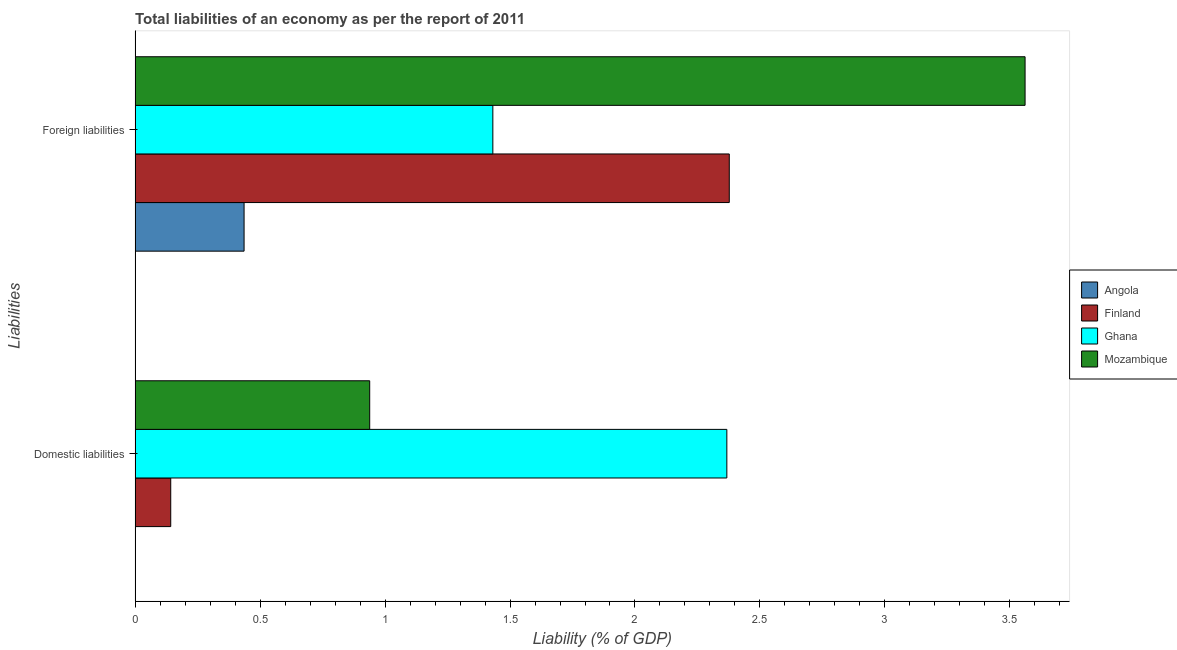How many groups of bars are there?
Give a very brief answer. 2. Are the number of bars on each tick of the Y-axis equal?
Your response must be concise. No. How many bars are there on the 1st tick from the top?
Provide a short and direct response. 4. What is the label of the 1st group of bars from the top?
Your answer should be compact. Foreign liabilities. What is the incurrence of foreign liabilities in Mozambique?
Make the answer very short. 3.56. Across all countries, what is the maximum incurrence of domestic liabilities?
Ensure brevity in your answer.  2.37. Across all countries, what is the minimum incurrence of foreign liabilities?
Offer a terse response. 0.44. In which country was the incurrence of foreign liabilities maximum?
Offer a terse response. Mozambique. What is the total incurrence of domestic liabilities in the graph?
Your response must be concise. 3.45. What is the difference between the incurrence of domestic liabilities in Ghana and that in Finland?
Keep it short and to the point. 2.22. What is the difference between the incurrence of foreign liabilities in Finland and the incurrence of domestic liabilities in Mozambique?
Your response must be concise. 1.44. What is the average incurrence of foreign liabilities per country?
Give a very brief answer. 1.95. What is the difference between the incurrence of foreign liabilities and incurrence of domestic liabilities in Finland?
Give a very brief answer. 2.23. In how many countries, is the incurrence of foreign liabilities greater than 1.1 %?
Keep it short and to the point. 3. What is the ratio of the incurrence of domestic liabilities in Ghana to that in Finland?
Your answer should be compact. 16.59. Is the incurrence of foreign liabilities in Finland less than that in Angola?
Ensure brevity in your answer.  No. Are all the bars in the graph horizontal?
Ensure brevity in your answer.  Yes. How many countries are there in the graph?
Make the answer very short. 4. What is the difference between two consecutive major ticks on the X-axis?
Your response must be concise. 0.5. Does the graph contain grids?
Offer a very short reply. No. How are the legend labels stacked?
Provide a short and direct response. Vertical. What is the title of the graph?
Your answer should be compact. Total liabilities of an economy as per the report of 2011. What is the label or title of the X-axis?
Offer a terse response. Liability (% of GDP). What is the label or title of the Y-axis?
Make the answer very short. Liabilities. What is the Liability (% of GDP) in Angola in Domestic liabilities?
Your answer should be compact. 0. What is the Liability (% of GDP) of Finland in Domestic liabilities?
Offer a terse response. 0.14. What is the Liability (% of GDP) in Ghana in Domestic liabilities?
Your answer should be very brief. 2.37. What is the Liability (% of GDP) of Mozambique in Domestic liabilities?
Make the answer very short. 0.94. What is the Liability (% of GDP) in Angola in Foreign liabilities?
Ensure brevity in your answer.  0.44. What is the Liability (% of GDP) of Finland in Foreign liabilities?
Give a very brief answer. 2.38. What is the Liability (% of GDP) in Ghana in Foreign liabilities?
Provide a short and direct response. 1.43. What is the Liability (% of GDP) in Mozambique in Foreign liabilities?
Ensure brevity in your answer.  3.56. Across all Liabilities, what is the maximum Liability (% of GDP) in Angola?
Offer a terse response. 0.44. Across all Liabilities, what is the maximum Liability (% of GDP) in Finland?
Give a very brief answer. 2.38. Across all Liabilities, what is the maximum Liability (% of GDP) of Ghana?
Offer a terse response. 2.37. Across all Liabilities, what is the maximum Liability (% of GDP) of Mozambique?
Give a very brief answer. 3.56. Across all Liabilities, what is the minimum Liability (% of GDP) of Finland?
Offer a very short reply. 0.14. Across all Liabilities, what is the minimum Liability (% of GDP) of Ghana?
Keep it short and to the point. 1.43. Across all Liabilities, what is the minimum Liability (% of GDP) in Mozambique?
Provide a short and direct response. 0.94. What is the total Liability (% of GDP) of Angola in the graph?
Your answer should be very brief. 0.44. What is the total Liability (% of GDP) in Finland in the graph?
Give a very brief answer. 2.52. What is the total Liability (% of GDP) in Ghana in the graph?
Provide a succinct answer. 3.8. What is the total Liability (% of GDP) of Mozambique in the graph?
Offer a terse response. 4.5. What is the difference between the Liability (% of GDP) in Finland in Domestic liabilities and that in Foreign liabilities?
Make the answer very short. -2.23. What is the difference between the Liability (% of GDP) of Ghana in Domestic liabilities and that in Foreign liabilities?
Ensure brevity in your answer.  0.94. What is the difference between the Liability (% of GDP) of Mozambique in Domestic liabilities and that in Foreign liabilities?
Your answer should be compact. -2.62. What is the difference between the Liability (% of GDP) in Finland in Domestic liabilities and the Liability (% of GDP) in Ghana in Foreign liabilities?
Give a very brief answer. -1.29. What is the difference between the Liability (% of GDP) of Finland in Domestic liabilities and the Liability (% of GDP) of Mozambique in Foreign liabilities?
Your answer should be very brief. -3.42. What is the difference between the Liability (% of GDP) in Ghana in Domestic liabilities and the Liability (% of GDP) in Mozambique in Foreign liabilities?
Provide a succinct answer. -1.19. What is the average Liability (% of GDP) in Angola per Liabilities?
Your answer should be very brief. 0.22. What is the average Liability (% of GDP) in Finland per Liabilities?
Your response must be concise. 1.26. What is the average Liability (% of GDP) of Ghana per Liabilities?
Offer a terse response. 1.9. What is the average Liability (% of GDP) of Mozambique per Liabilities?
Your answer should be compact. 2.25. What is the difference between the Liability (% of GDP) of Finland and Liability (% of GDP) of Ghana in Domestic liabilities?
Your response must be concise. -2.22. What is the difference between the Liability (% of GDP) of Finland and Liability (% of GDP) of Mozambique in Domestic liabilities?
Ensure brevity in your answer.  -0.8. What is the difference between the Liability (% of GDP) of Ghana and Liability (% of GDP) of Mozambique in Domestic liabilities?
Offer a terse response. 1.43. What is the difference between the Liability (% of GDP) in Angola and Liability (% of GDP) in Finland in Foreign liabilities?
Make the answer very short. -1.94. What is the difference between the Liability (% of GDP) in Angola and Liability (% of GDP) in Ghana in Foreign liabilities?
Give a very brief answer. -1. What is the difference between the Liability (% of GDP) in Angola and Liability (% of GDP) in Mozambique in Foreign liabilities?
Offer a terse response. -3.12. What is the difference between the Liability (% of GDP) of Finland and Liability (% of GDP) of Ghana in Foreign liabilities?
Offer a terse response. 0.95. What is the difference between the Liability (% of GDP) in Finland and Liability (% of GDP) in Mozambique in Foreign liabilities?
Your answer should be very brief. -1.18. What is the difference between the Liability (% of GDP) in Ghana and Liability (% of GDP) in Mozambique in Foreign liabilities?
Provide a succinct answer. -2.13. What is the ratio of the Liability (% of GDP) in Ghana in Domestic liabilities to that in Foreign liabilities?
Offer a terse response. 1.65. What is the ratio of the Liability (% of GDP) of Mozambique in Domestic liabilities to that in Foreign liabilities?
Your answer should be very brief. 0.26. What is the difference between the highest and the second highest Liability (% of GDP) in Finland?
Keep it short and to the point. 2.23. What is the difference between the highest and the second highest Liability (% of GDP) of Ghana?
Your answer should be very brief. 0.94. What is the difference between the highest and the second highest Liability (% of GDP) of Mozambique?
Offer a very short reply. 2.62. What is the difference between the highest and the lowest Liability (% of GDP) in Angola?
Your response must be concise. 0.44. What is the difference between the highest and the lowest Liability (% of GDP) of Finland?
Offer a terse response. 2.23. What is the difference between the highest and the lowest Liability (% of GDP) in Ghana?
Offer a terse response. 0.94. What is the difference between the highest and the lowest Liability (% of GDP) of Mozambique?
Provide a succinct answer. 2.62. 